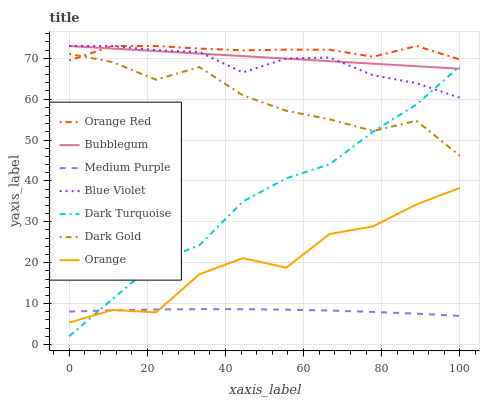Does Medium Purple have the minimum area under the curve?
Answer yes or no. Yes. Does Orange Red have the maximum area under the curve?
Answer yes or no. Yes. Does Dark Turquoise have the minimum area under the curve?
Answer yes or no. No. Does Dark Turquoise have the maximum area under the curve?
Answer yes or no. No. Is Bubblegum the smoothest?
Answer yes or no. Yes. Is Orange the roughest?
Answer yes or no. Yes. Is Dark Turquoise the smoothest?
Answer yes or no. No. Is Dark Turquoise the roughest?
Answer yes or no. No. Does Dark Turquoise have the lowest value?
Answer yes or no. Yes. Does Bubblegum have the lowest value?
Answer yes or no. No. Does Blue Violet have the highest value?
Answer yes or no. Yes. Does Dark Turquoise have the highest value?
Answer yes or no. No. Is Medium Purple less than Dark Gold?
Answer yes or no. Yes. Is Dark Gold greater than Medium Purple?
Answer yes or no. Yes. Does Blue Violet intersect Orange Red?
Answer yes or no. Yes. Is Blue Violet less than Orange Red?
Answer yes or no. No. Is Blue Violet greater than Orange Red?
Answer yes or no. No. Does Medium Purple intersect Dark Gold?
Answer yes or no. No. 